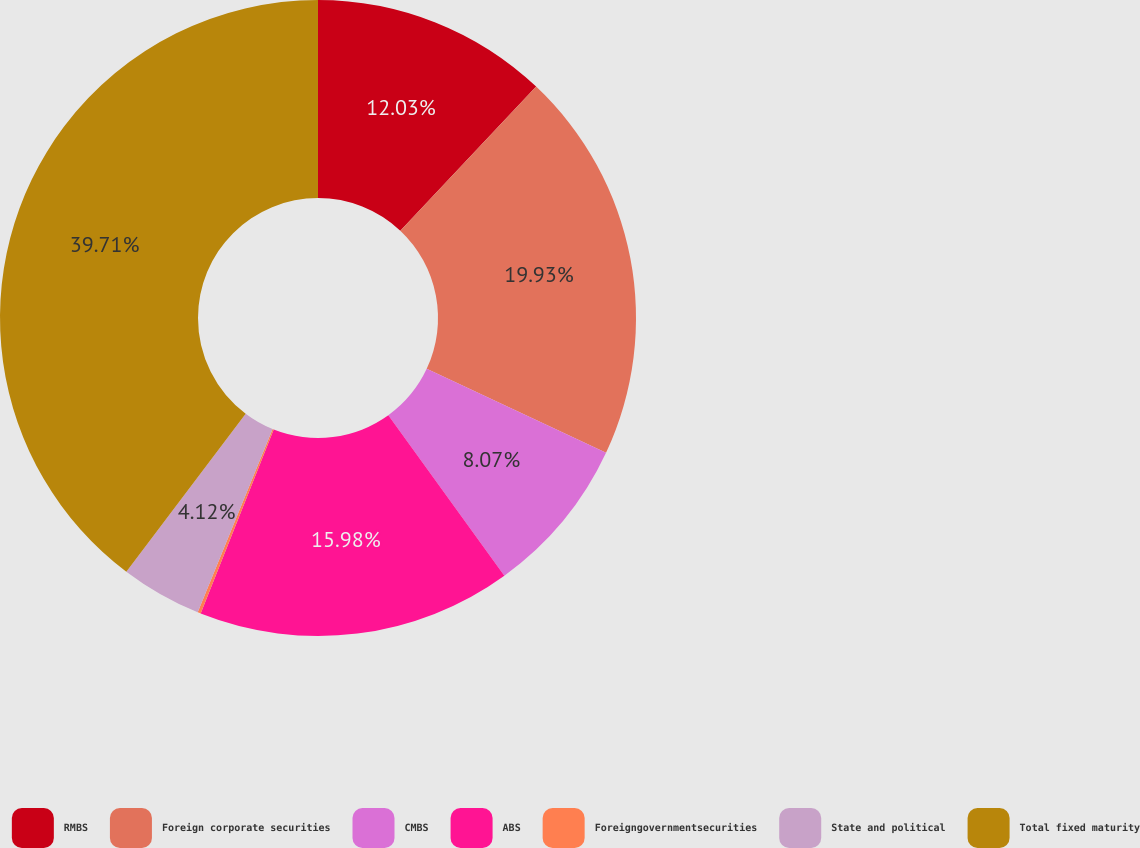Convert chart to OTSL. <chart><loc_0><loc_0><loc_500><loc_500><pie_chart><fcel>RMBS<fcel>Foreign corporate securities<fcel>CMBS<fcel>ABS<fcel>Foreigngovernmentsecurities<fcel>State and political<fcel>Total fixed maturity<nl><fcel>12.03%<fcel>19.93%<fcel>8.07%<fcel>15.98%<fcel>0.16%<fcel>4.12%<fcel>39.7%<nl></chart> 